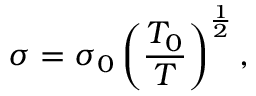<formula> <loc_0><loc_0><loc_500><loc_500>\sigma = \sigma _ { 0 } \left ( { \frac { T _ { 0 } } { T } } \right ) ^ { \frac { 1 } { 2 } } ,</formula> 